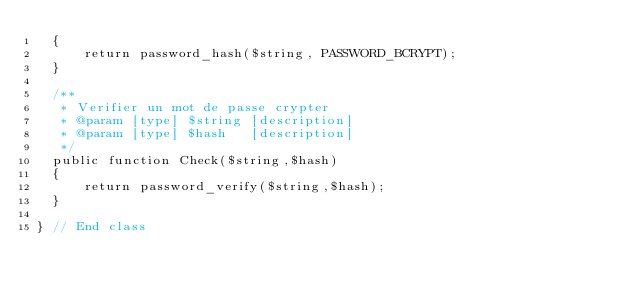Convert code to text. <code><loc_0><loc_0><loc_500><loc_500><_PHP_>  {
      return password_hash($string, PASSWORD_BCRYPT);
  }

  /**
   * Verifier un mot de passe crypter
   * @param [type] $string [description]
   * @param [type] $hash   [description]
   */
  public function Check($string,$hash)
  {
      return password_verify($string,$hash);
  }

} // End class
</code> 